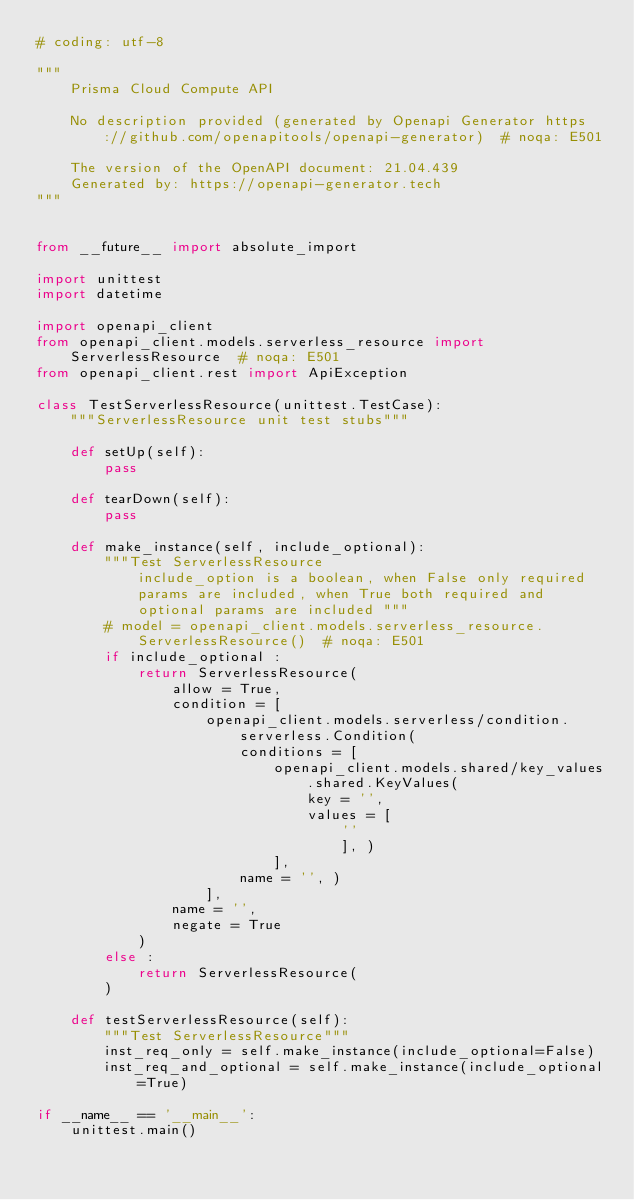Convert code to text. <code><loc_0><loc_0><loc_500><loc_500><_Python_># coding: utf-8

"""
    Prisma Cloud Compute API

    No description provided (generated by Openapi Generator https://github.com/openapitools/openapi-generator)  # noqa: E501

    The version of the OpenAPI document: 21.04.439
    Generated by: https://openapi-generator.tech
"""


from __future__ import absolute_import

import unittest
import datetime

import openapi_client
from openapi_client.models.serverless_resource import ServerlessResource  # noqa: E501
from openapi_client.rest import ApiException

class TestServerlessResource(unittest.TestCase):
    """ServerlessResource unit test stubs"""

    def setUp(self):
        pass

    def tearDown(self):
        pass

    def make_instance(self, include_optional):
        """Test ServerlessResource
            include_option is a boolean, when False only required
            params are included, when True both required and
            optional params are included """
        # model = openapi_client.models.serverless_resource.ServerlessResource()  # noqa: E501
        if include_optional :
            return ServerlessResource(
                allow = True, 
                condition = [
                    openapi_client.models.serverless/condition.serverless.Condition(
                        conditions = [
                            openapi_client.models.shared/key_values.shared.KeyValues(
                                key = '', 
                                values = [
                                    ''
                                    ], )
                            ], 
                        name = '', )
                    ], 
                name = '', 
                negate = True
            )
        else :
            return ServerlessResource(
        )

    def testServerlessResource(self):
        """Test ServerlessResource"""
        inst_req_only = self.make_instance(include_optional=False)
        inst_req_and_optional = self.make_instance(include_optional=True)

if __name__ == '__main__':
    unittest.main()
</code> 